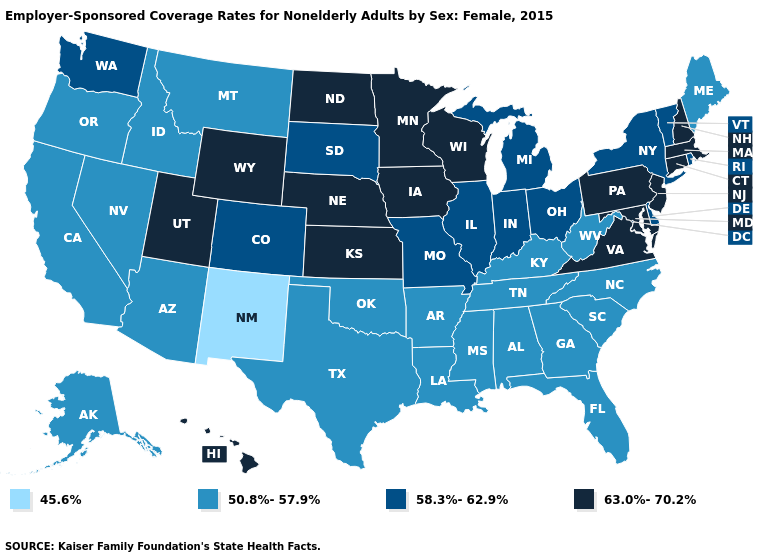What is the value of Wyoming?
Short answer required. 63.0%-70.2%. How many symbols are there in the legend?
Short answer required. 4. What is the value of Louisiana?
Short answer required. 50.8%-57.9%. Does Nebraska have the highest value in the MidWest?
Keep it brief. Yes. Name the states that have a value in the range 63.0%-70.2%?
Give a very brief answer. Connecticut, Hawaii, Iowa, Kansas, Maryland, Massachusetts, Minnesota, Nebraska, New Hampshire, New Jersey, North Dakota, Pennsylvania, Utah, Virginia, Wisconsin, Wyoming. Does Montana have the highest value in the West?
Short answer required. No. Name the states that have a value in the range 58.3%-62.9%?
Concise answer only. Colorado, Delaware, Illinois, Indiana, Michigan, Missouri, New York, Ohio, Rhode Island, South Dakota, Vermont, Washington. Does the map have missing data?
Concise answer only. No. Does Indiana have the highest value in the MidWest?
Quick response, please. No. What is the value of Idaho?
Concise answer only. 50.8%-57.9%. Name the states that have a value in the range 58.3%-62.9%?
Quick response, please. Colorado, Delaware, Illinois, Indiana, Michigan, Missouri, New York, Ohio, Rhode Island, South Dakota, Vermont, Washington. Name the states that have a value in the range 45.6%?
Give a very brief answer. New Mexico. What is the value of New York?
Give a very brief answer. 58.3%-62.9%. Among the states that border Indiana , does Kentucky have the lowest value?
Answer briefly. Yes. Among the states that border Oregon , which have the highest value?
Short answer required. Washington. 